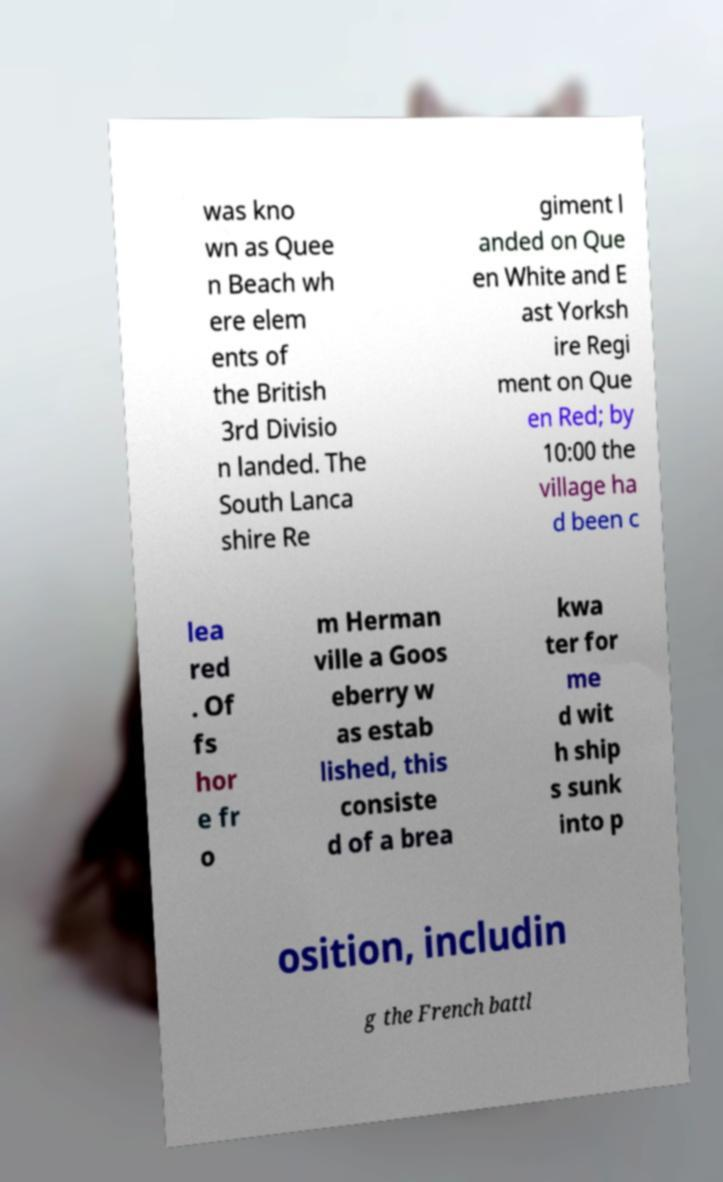Can you accurately transcribe the text from the provided image for me? was kno wn as Quee n Beach wh ere elem ents of the British 3rd Divisio n landed. The South Lanca shire Re giment l anded on Que en White and E ast Yorksh ire Regi ment on Que en Red; by 10:00 the village ha d been c lea red . Of fs hor e fr o m Herman ville a Goos eberry w as estab lished, this consiste d of a brea kwa ter for me d wit h ship s sunk into p osition, includin g the French battl 